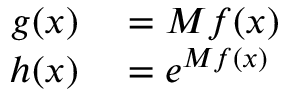Convert formula to latex. <formula><loc_0><loc_0><loc_500><loc_500>\begin{array} { r l } { g ( x ) } & = M f ( x ) } \\ { h ( x ) } & = e ^ { M f ( x ) } } \end{array}</formula> 